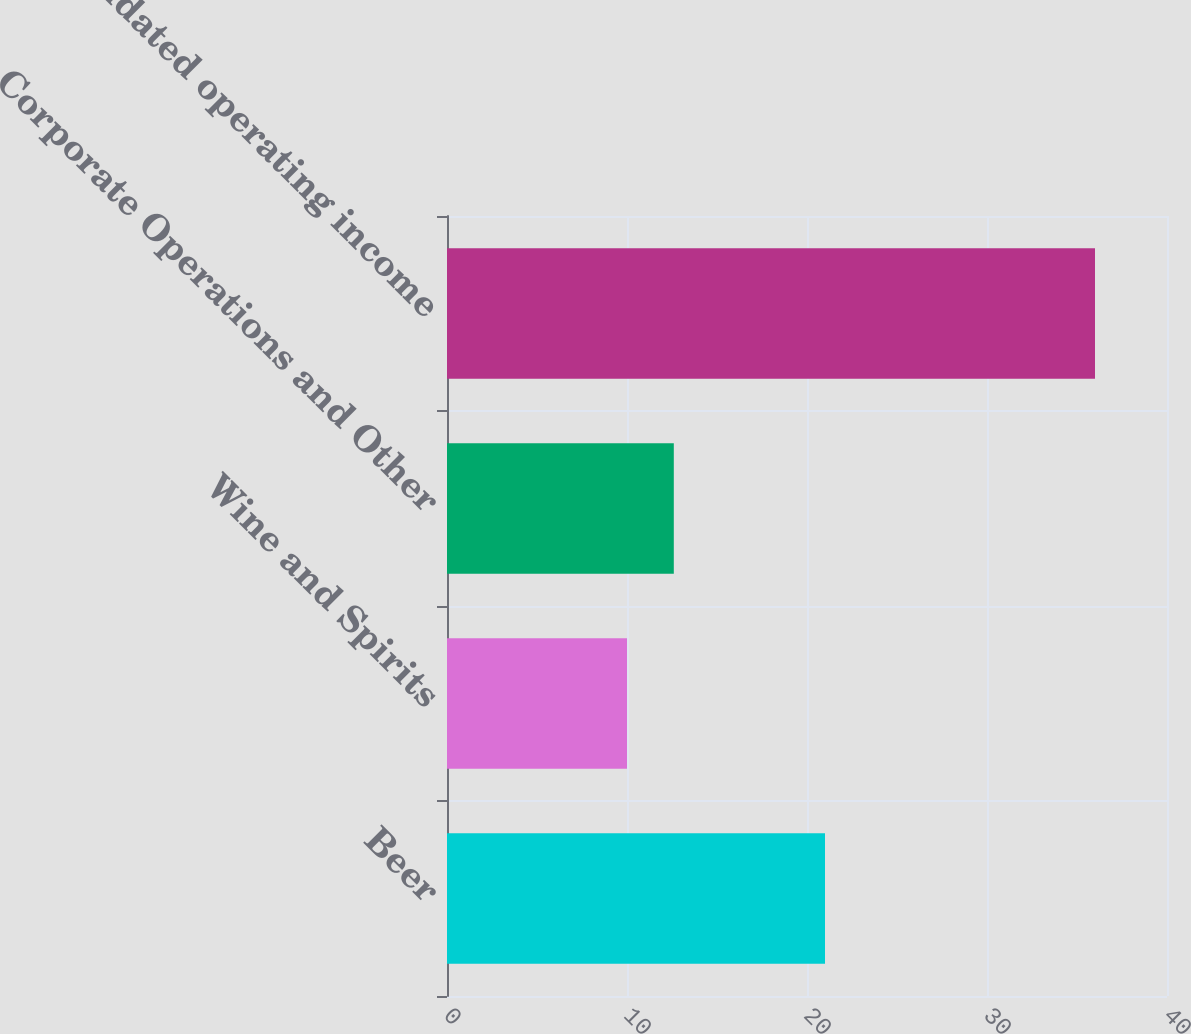Convert chart to OTSL. <chart><loc_0><loc_0><loc_500><loc_500><bar_chart><fcel>Beer<fcel>Wine and Spirits<fcel>Corporate Operations and Other<fcel>Consolidated operating income<nl><fcel>21<fcel>10<fcel>12.6<fcel>36<nl></chart> 